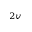Convert formula to latex. <formula><loc_0><loc_0><loc_500><loc_500>_ { 2 v }</formula> 